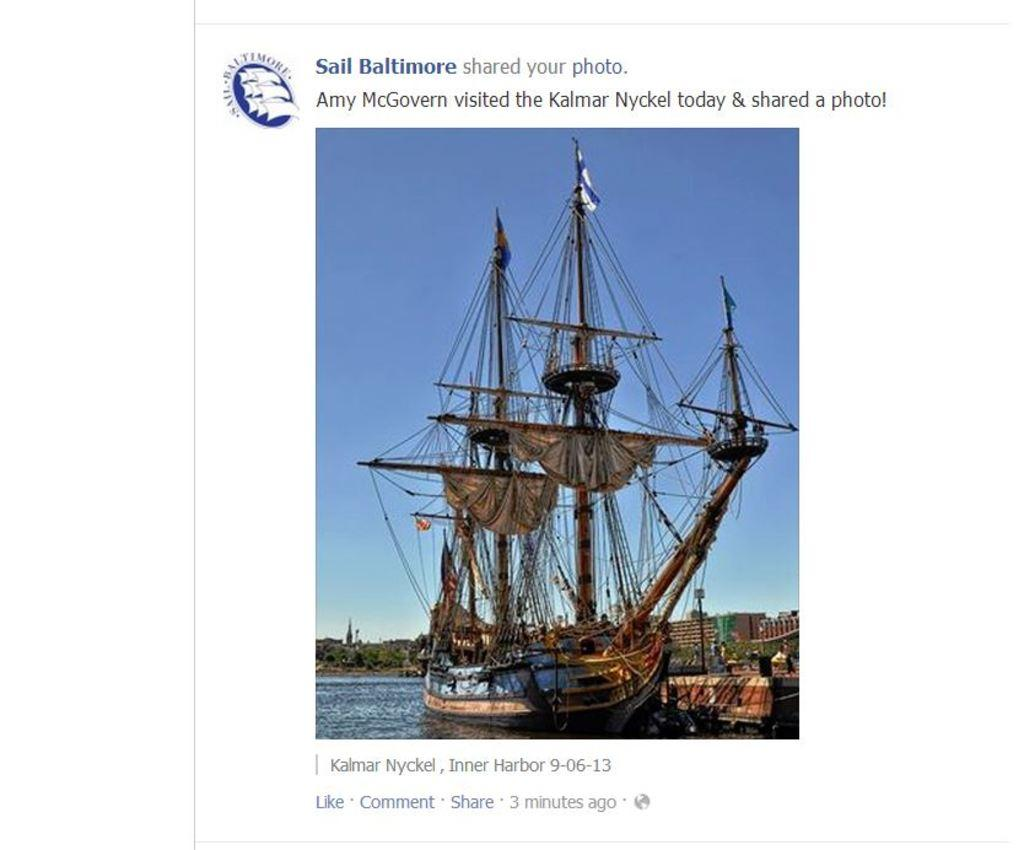What is the main subject of the image? The main subject of the image is a boat. Where is the boat located? The boat is on a lake. What else can be seen in the image besides the boat? Buildings, the sky, trees, text, a logo, and ropes on the boat are visible in the image. Can you hear the boat crying in the image? There is no sound in the image, and boats do not have the ability to cry. What type of stone is used to build the buildings in the image? There is no information about the materials used to build the buildings in the image. 